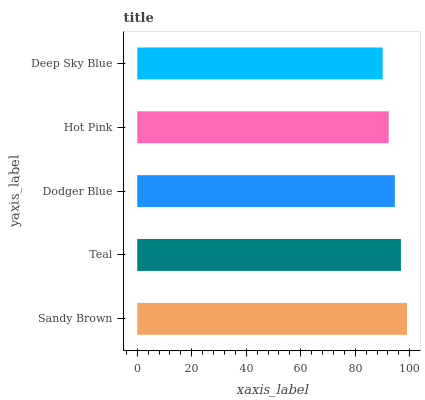Is Deep Sky Blue the minimum?
Answer yes or no. Yes. Is Sandy Brown the maximum?
Answer yes or no. Yes. Is Teal the minimum?
Answer yes or no. No. Is Teal the maximum?
Answer yes or no. No. Is Sandy Brown greater than Teal?
Answer yes or no. Yes. Is Teal less than Sandy Brown?
Answer yes or no. Yes. Is Teal greater than Sandy Brown?
Answer yes or no. No. Is Sandy Brown less than Teal?
Answer yes or no. No. Is Dodger Blue the high median?
Answer yes or no. Yes. Is Dodger Blue the low median?
Answer yes or no. Yes. Is Hot Pink the high median?
Answer yes or no. No. Is Sandy Brown the low median?
Answer yes or no. No. 